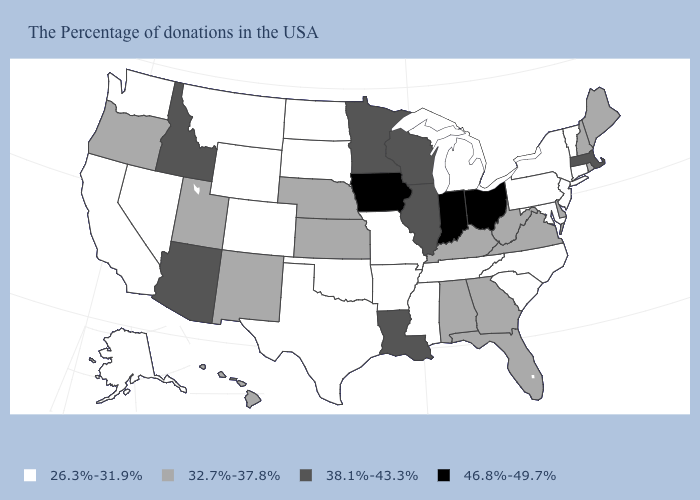Name the states that have a value in the range 32.7%-37.8%?
Concise answer only. Maine, Rhode Island, New Hampshire, Delaware, Virginia, West Virginia, Florida, Georgia, Kentucky, Alabama, Kansas, Nebraska, New Mexico, Utah, Oregon, Hawaii. Does West Virginia have a lower value than Louisiana?
Answer briefly. Yes. How many symbols are there in the legend?
Answer briefly. 4. What is the value of Kentucky?
Be succinct. 32.7%-37.8%. What is the value of South Carolina?
Write a very short answer. 26.3%-31.9%. Name the states that have a value in the range 38.1%-43.3%?
Write a very short answer. Massachusetts, Wisconsin, Illinois, Louisiana, Minnesota, Arizona, Idaho. What is the value of Missouri?
Give a very brief answer. 26.3%-31.9%. Name the states that have a value in the range 38.1%-43.3%?
Give a very brief answer. Massachusetts, Wisconsin, Illinois, Louisiana, Minnesota, Arizona, Idaho. What is the value of Hawaii?
Give a very brief answer. 32.7%-37.8%. Does Arkansas have the same value as Nebraska?
Be succinct. No. Name the states that have a value in the range 26.3%-31.9%?
Be succinct. Vermont, Connecticut, New York, New Jersey, Maryland, Pennsylvania, North Carolina, South Carolina, Michigan, Tennessee, Mississippi, Missouri, Arkansas, Oklahoma, Texas, South Dakota, North Dakota, Wyoming, Colorado, Montana, Nevada, California, Washington, Alaska. Does New Jersey have the same value as Utah?
Write a very short answer. No. What is the value of Alabama?
Answer briefly. 32.7%-37.8%. What is the highest value in states that border Ohio?
Quick response, please. 46.8%-49.7%. Name the states that have a value in the range 38.1%-43.3%?
Concise answer only. Massachusetts, Wisconsin, Illinois, Louisiana, Minnesota, Arizona, Idaho. 